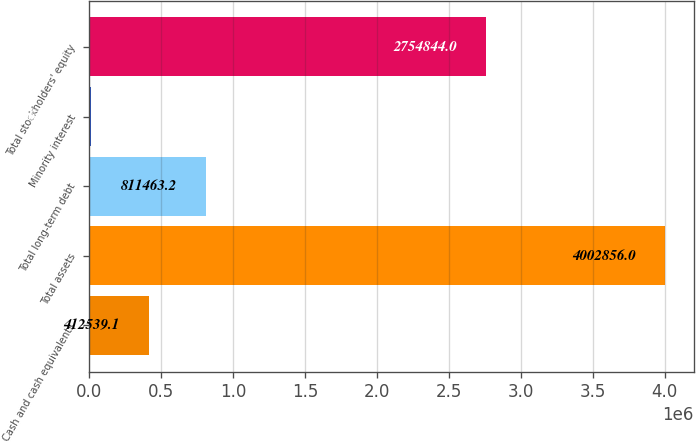Convert chart to OTSL. <chart><loc_0><loc_0><loc_500><loc_500><bar_chart><fcel>Cash and cash equivalents<fcel>Total assets<fcel>Total long-term debt<fcel>Minority interest<fcel>Total stockholders' equity<nl><fcel>412539<fcel>4.00286e+06<fcel>811463<fcel>13615<fcel>2.75484e+06<nl></chart> 